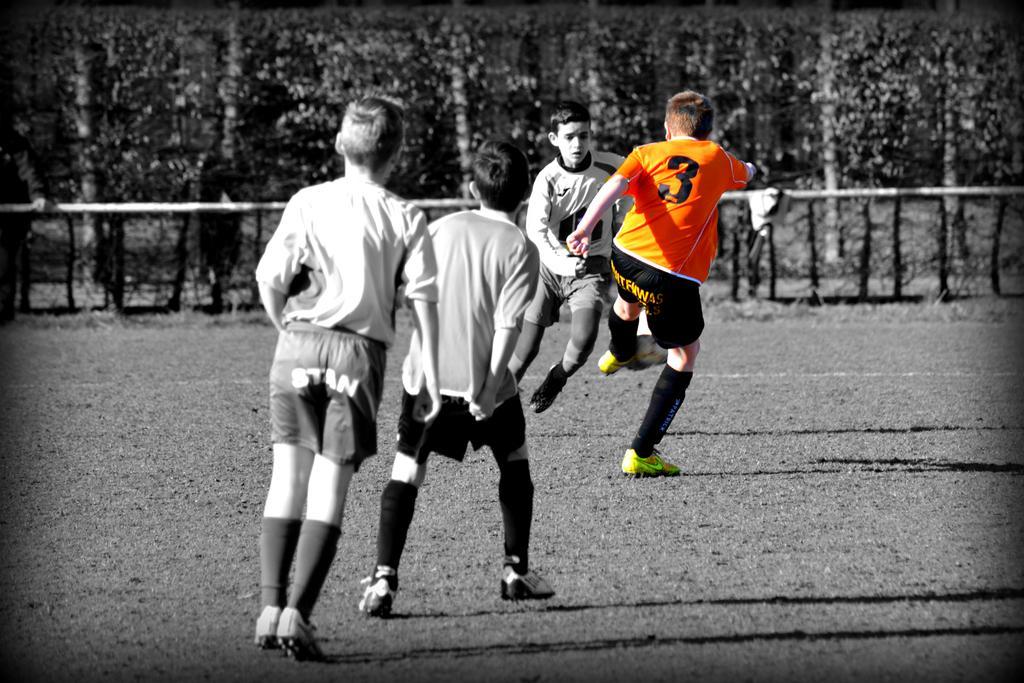In one or two sentences, can you explain what this image depicts? In the picture there are four children playing football in the ground there are many trees near to the ground there is a pole near to the ground. 